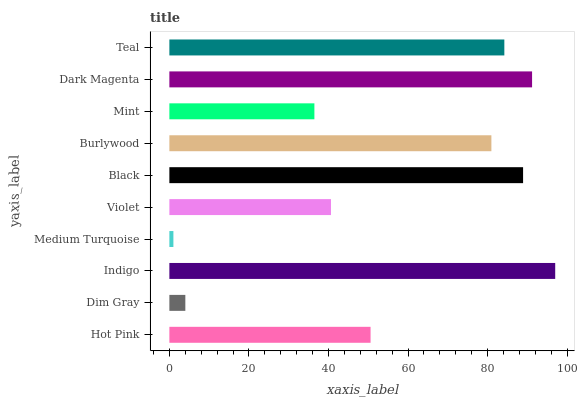Is Medium Turquoise the minimum?
Answer yes or no. Yes. Is Indigo the maximum?
Answer yes or no. Yes. Is Dim Gray the minimum?
Answer yes or no. No. Is Dim Gray the maximum?
Answer yes or no. No. Is Hot Pink greater than Dim Gray?
Answer yes or no. Yes. Is Dim Gray less than Hot Pink?
Answer yes or no. Yes. Is Dim Gray greater than Hot Pink?
Answer yes or no. No. Is Hot Pink less than Dim Gray?
Answer yes or no. No. Is Burlywood the high median?
Answer yes or no. Yes. Is Hot Pink the low median?
Answer yes or no. Yes. Is Violet the high median?
Answer yes or no. No. Is Dark Magenta the low median?
Answer yes or no. No. 